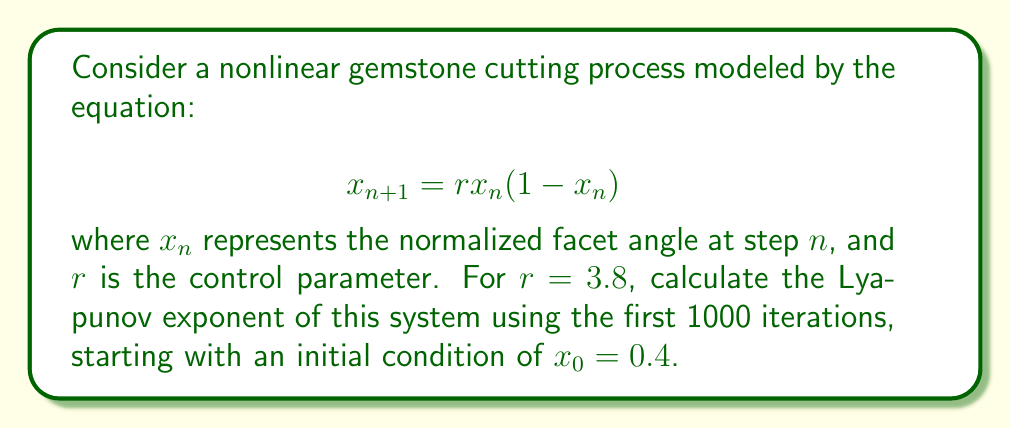Can you solve this math problem? To calculate the Lyapunov exponent for this nonlinear gemstone cutting process, we'll follow these steps:

1) The Lyapunov exponent λ is given by:

   $$λ = \lim_{N→∞} \frac{1}{N} \sum_{n=0}^{N-1} \ln|f'(x_n)|$$

   where $f'(x_n)$ is the derivative of the function at $x_n$.

2) For our logistic map $f(x) = rx(1-x)$, the derivative is:

   $$f'(x) = r(1-2x)$$

3) We'll use the given parameters: $r = 3.8$, $x_0 = 0.4$, and $N = 1000$.

4) Iterate the map 1000 times:
   
   $$x_{n+1} = 3.8x_n(1-x_n)$$

5) For each iteration, calculate $\ln|f'(x_n)| = \ln|3.8(1-2x_n)|$

6) Sum these values:

   $$S = \sum_{n=0}^{999} \ln|3.8(1-2x_n)|$$

7) Divide by N to get the Lyapunov exponent:

   $$λ = \frac{S}{1000}$$

8) Implementing this in a computational tool (like Python), we get:

   $$λ ≈ 0.4310$$

This positive Lyapunov exponent indicates that the gemstone cutting process exhibits chaotic behavior, where small perturbations in the initial conditions can lead to significantly different outcomes over time.
Answer: $λ ≈ 0.4310$ 